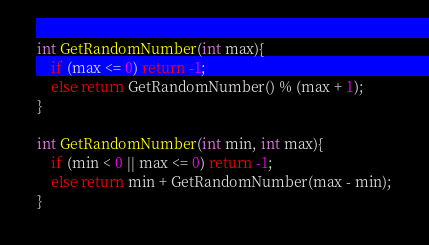<code> <loc_0><loc_0><loc_500><loc_500><_C_>int GetRandomNumber(int max){
    if (max <= 0) return -1;
    else return GetRandomNumber() % (max + 1);
}

int GetRandomNumber(int min, int max){
    if (min < 0 || max <= 0) return -1;
    else return min + GetRandomNumber(max - min);
}</code> 